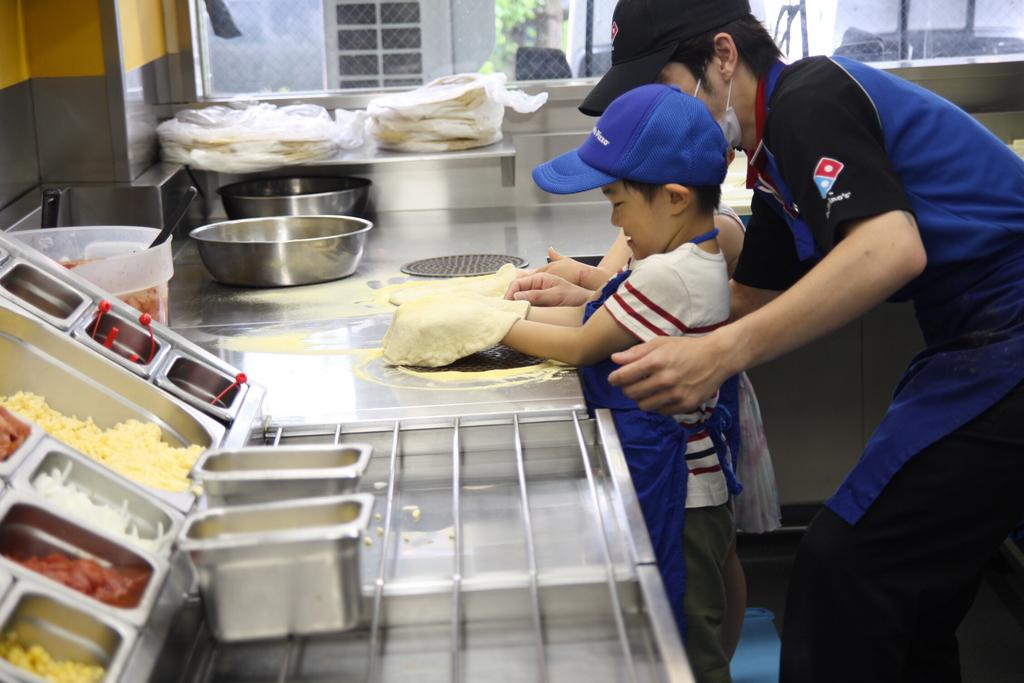What type of room is the image taken in? The image is taken inside a kitchen. How many people are present in the image? There are two people in the image. Where are the people located in the image? The people are standing at the right side of the image. What are the people wearing on their heads? The people are wearing caps. What type of knowledge is the mother passing on to her child in the image? There is no mother or child present in the image, and no knowledge being passed on. 